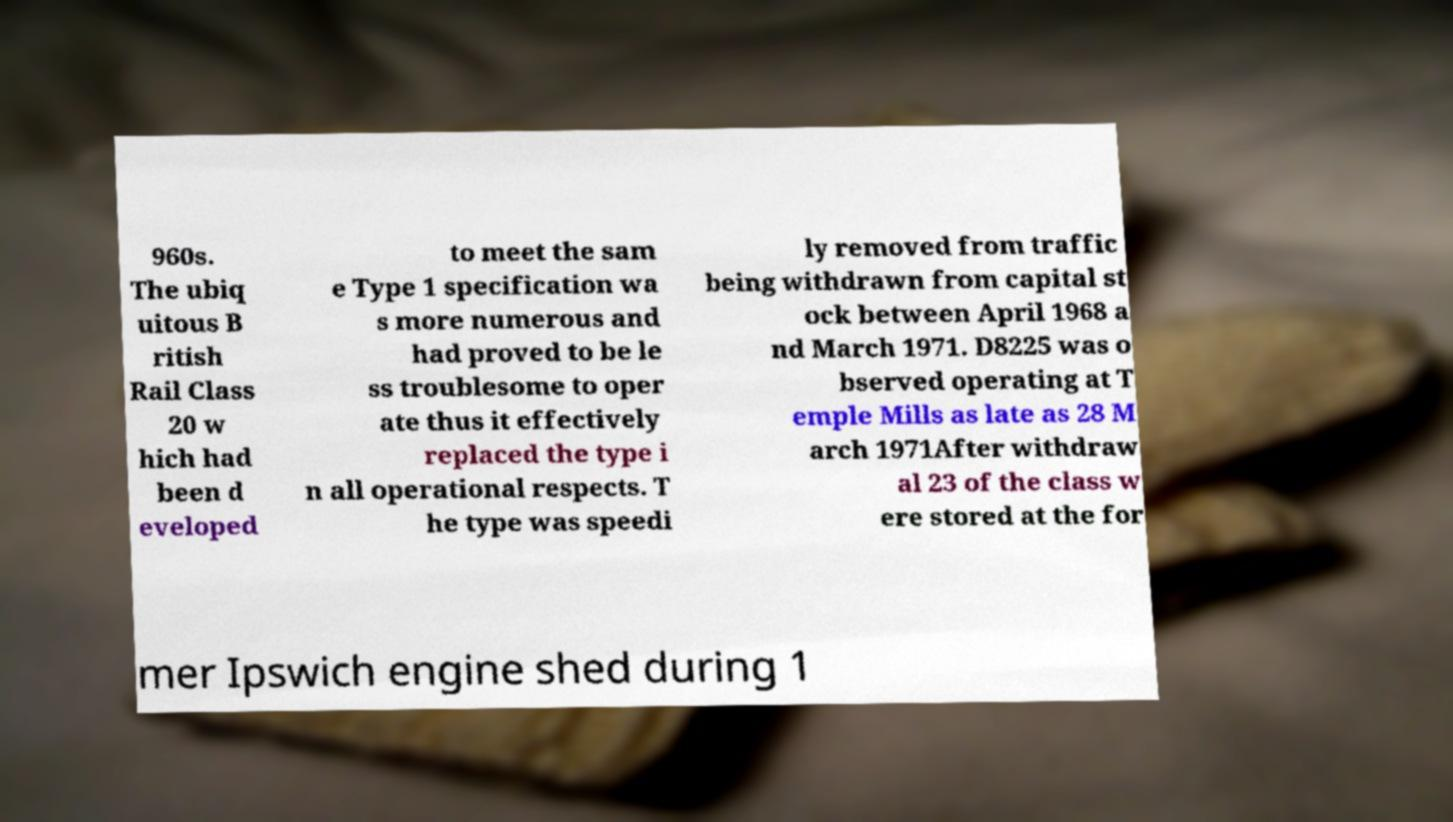Please read and relay the text visible in this image. What does it say? 960s. The ubiq uitous B ritish Rail Class 20 w hich had been d eveloped to meet the sam e Type 1 specification wa s more numerous and had proved to be le ss troublesome to oper ate thus it effectively replaced the type i n all operational respects. T he type was speedi ly removed from traffic being withdrawn from capital st ock between April 1968 a nd March 1971. D8225 was o bserved operating at T emple Mills as late as 28 M arch 1971After withdraw al 23 of the class w ere stored at the for mer Ipswich engine shed during 1 